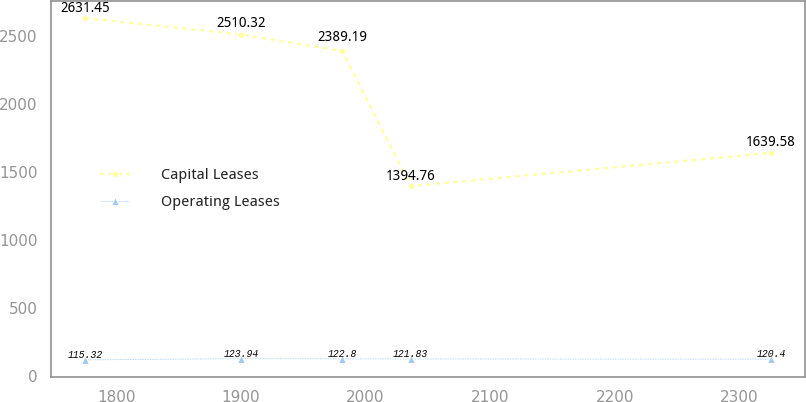<chart> <loc_0><loc_0><loc_500><loc_500><line_chart><ecel><fcel>Capital Leases<fcel>Operating Leases<nl><fcel>1774.76<fcel>2631.45<fcel>115.32<nl><fcel>1900.16<fcel>2510.32<fcel>123.94<nl><fcel>1981.32<fcel>2389.19<fcel>122.8<nl><fcel>2036.41<fcel>1394.76<fcel>121.83<nl><fcel>2325.63<fcel>1639.58<fcel>120.4<nl></chart> 